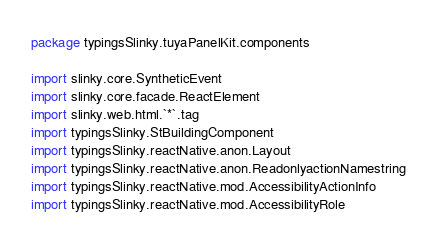Convert code to text. <code><loc_0><loc_0><loc_500><loc_500><_Scala_>package typingsSlinky.tuyaPanelKit.components

import slinky.core.SyntheticEvent
import slinky.core.facade.ReactElement
import slinky.web.html.`*`.tag
import typingsSlinky.StBuildingComponent
import typingsSlinky.reactNative.anon.Layout
import typingsSlinky.reactNative.anon.ReadonlyactionNamestring
import typingsSlinky.reactNative.mod.AccessibilityActionInfo
import typingsSlinky.reactNative.mod.AccessibilityRole</code> 